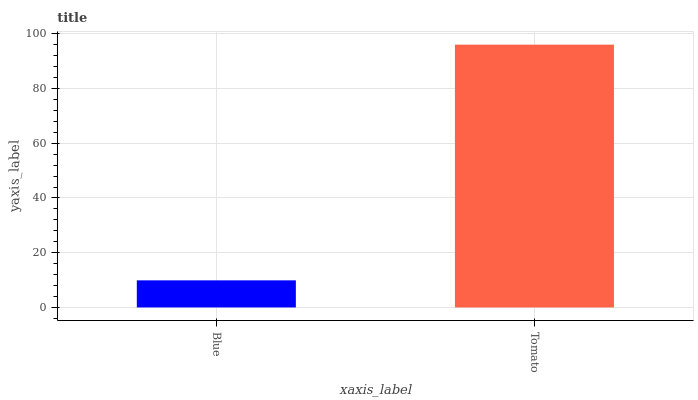Is Blue the minimum?
Answer yes or no. Yes. Is Tomato the maximum?
Answer yes or no. Yes. Is Tomato the minimum?
Answer yes or no. No. Is Tomato greater than Blue?
Answer yes or no. Yes. Is Blue less than Tomato?
Answer yes or no. Yes. Is Blue greater than Tomato?
Answer yes or no. No. Is Tomato less than Blue?
Answer yes or no. No. Is Tomato the high median?
Answer yes or no. Yes. Is Blue the low median?
Answer yes or no. Yes. Is Blue the high median?
Answer yes or no. No. Is Tomato the low median?
Answer yes or no. No. 